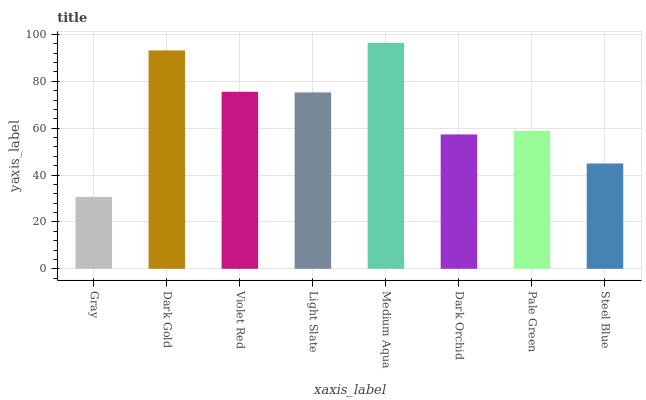Is Gray the minimum?
Answer yes or no. Yes. Is Medium Aqua the maximum?
Answer yes or no. Yes. Is Dark Gold the minimum?
Answer yes or no. No. Is Dark Gold the maximum?
Answer yes or no. No. Is Dark Gold greater than Gray?
Answer yes or no. Yes. Is Gray less than Dark Gold?
Answer yes or no. Yes. Is Gray greater than Dark Gold?
Answer yes or no. No. Is Dark Gold less than Gray?
Answer yes or no. No. Is Light Slate the high median?
Answer yes or no. Yes. Is Pale Green the low median?
Answer yes or no. Yes. Is Violet Red the high median?
Answer yes or no. No. Is Dark Orchid the low median?
Answer yes or no. No. 